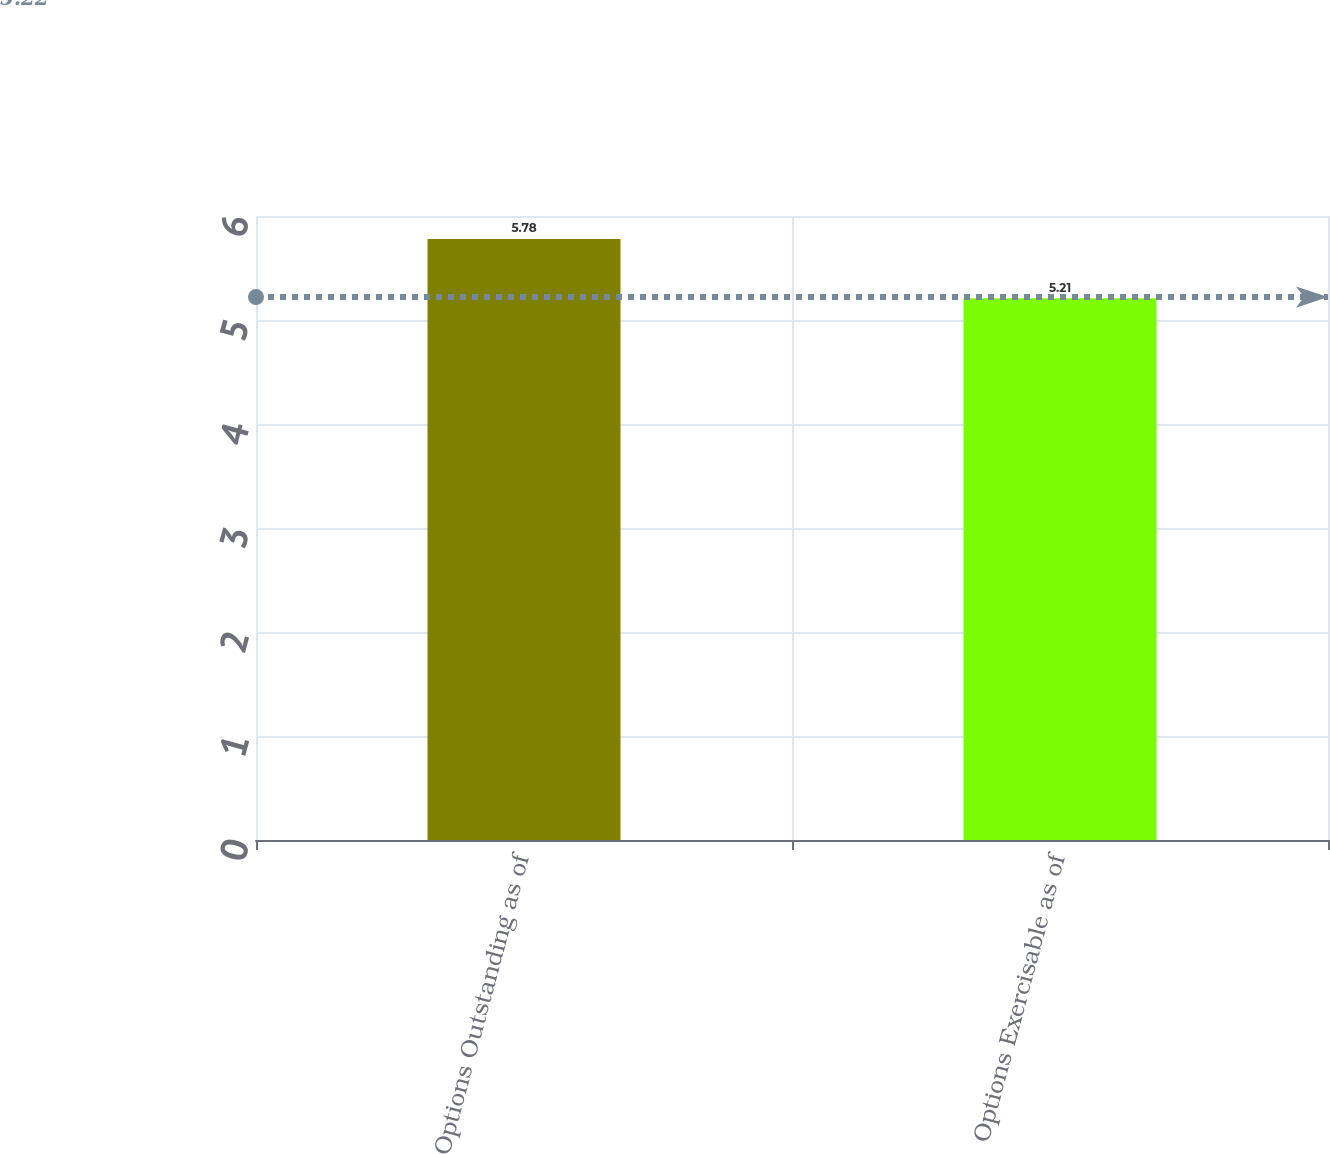<chart> <loc_0><loc_0><loc_500><loc_500><bar_chart><fcel>Options Outstanding as of<fcel>Options Exercisable as of<nl><fcel>5.78<fcel>5.21<nl></chart> 